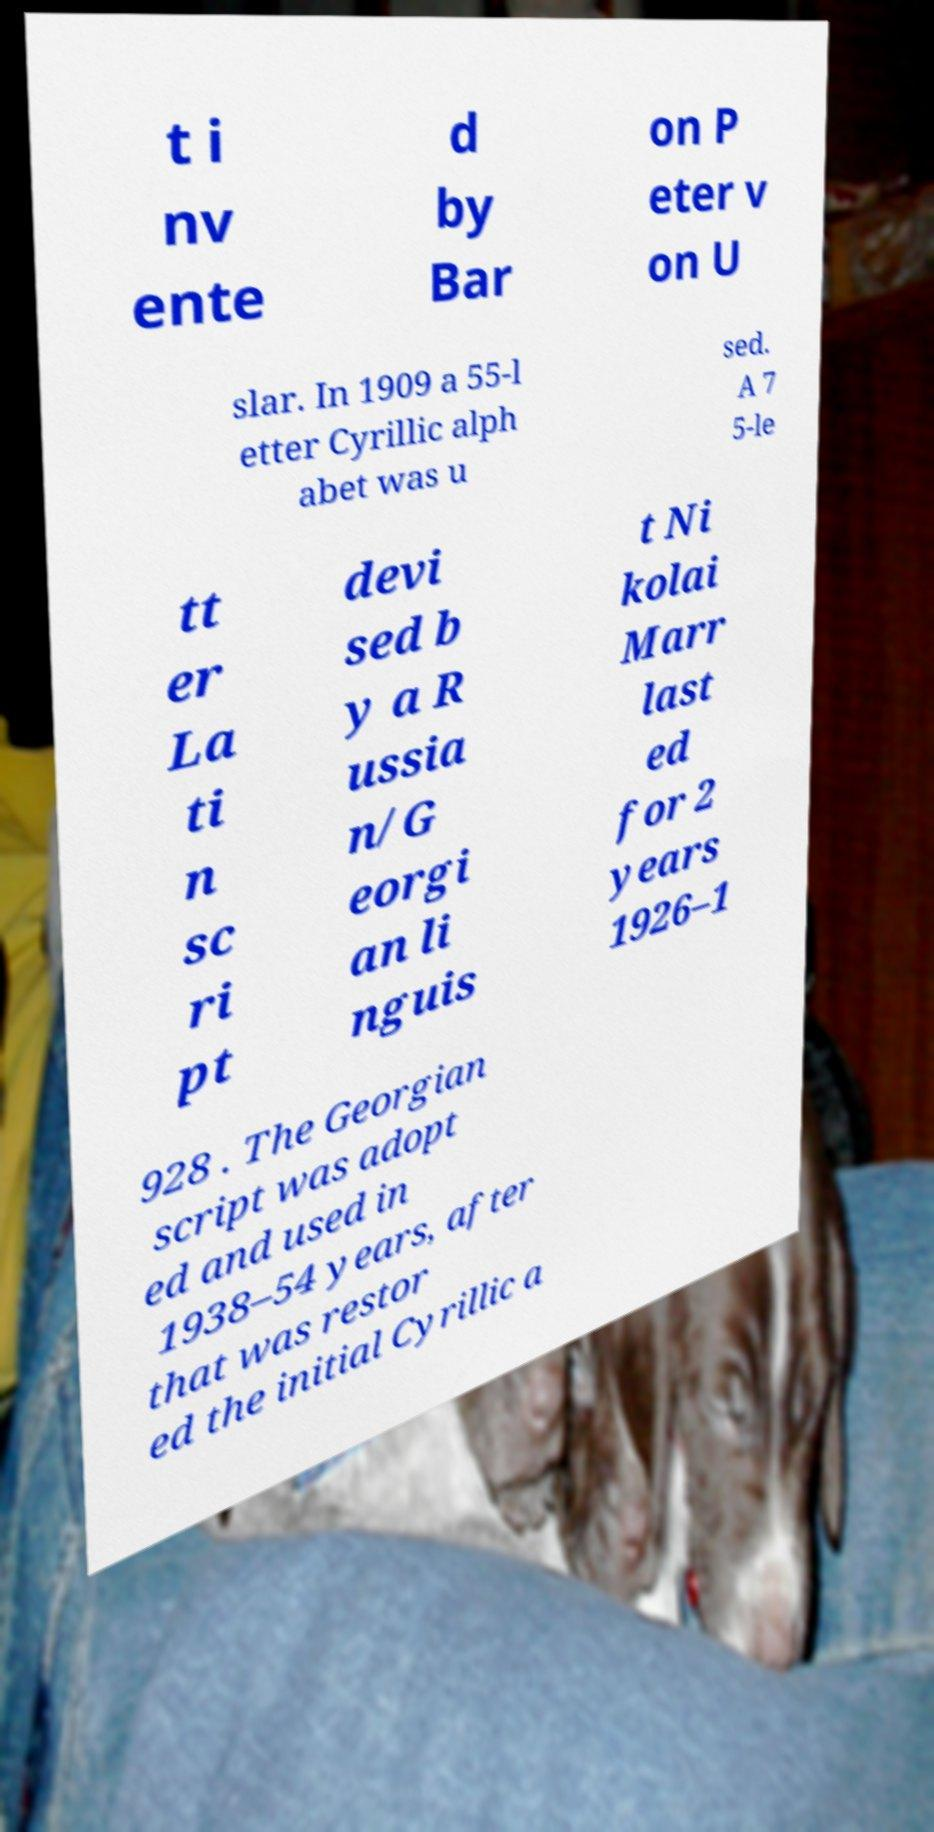I need the written content from this picture converted into text. Can you do that? t i nv ente d by Bar on P eter v on U slar. In 1909 a 55-l etter Cyrillic alph abet was u sed. A 7 5-le tt er La ti n sc ri pt devi sed b y a R ussia n/G eorgi an li nguis t Ni kolai Marr last ed for 2 years 1926–1 928 . The Georgian script was adopt ed and used in 1938–54 years, after that was restor ed the initial Cyrillic a 